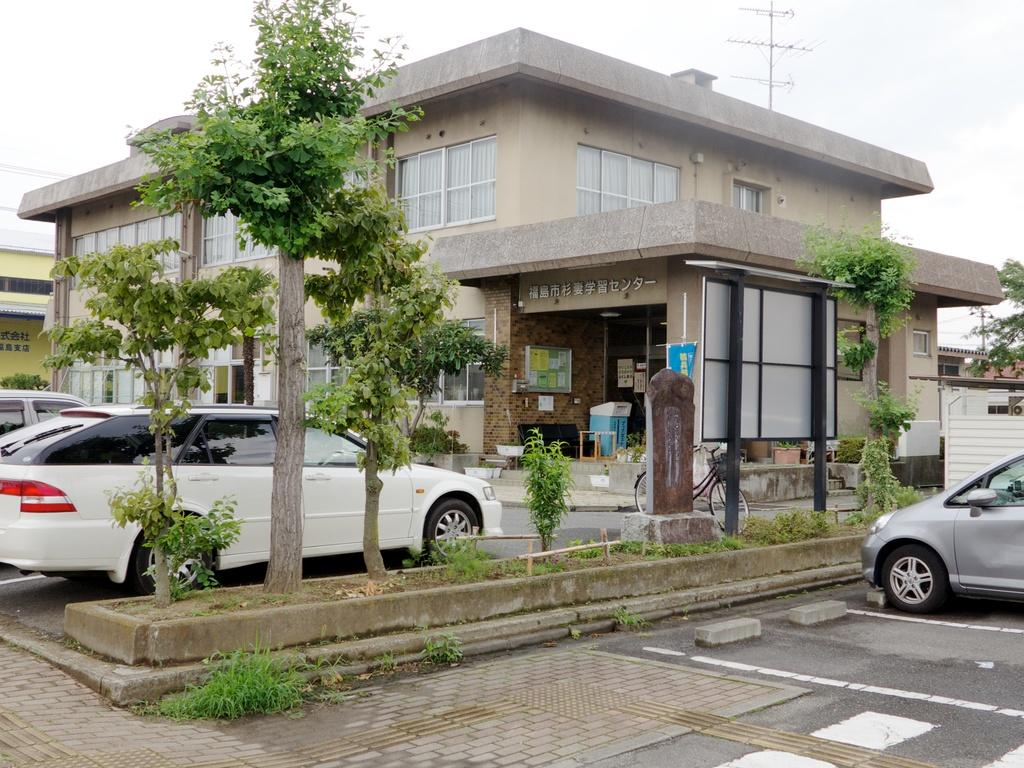What type of structures can be seen in the image? There are buildings in the image. What else is present in the image besides buildings? There are cars, plants, and trees in the image. What part of the natural environment is visible in the image? The sky is visible in the image. Where is the throne located in the image? There is no throne present in the image. Can you tell me if the image is hot or cold? The image does not convey temperature information, so it cannot be determined if the image is hot or cold. 